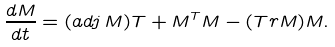Convert formula to latex. <formula><loc_0><loc_0><loc_500><loc_500>\frac { d M } { d t } = ( a d j \, M ) T + M ^ { T } M - ( T r M ) M .</formula> 